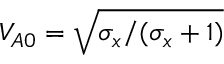Convert formula to latex. <formula><loc_0><loc_0><loc_500><loc_500>V _ { A 0 } = \sqrt { \sigma _ { x } / ( \sigma _ { x } + 1 ) }</formula> 